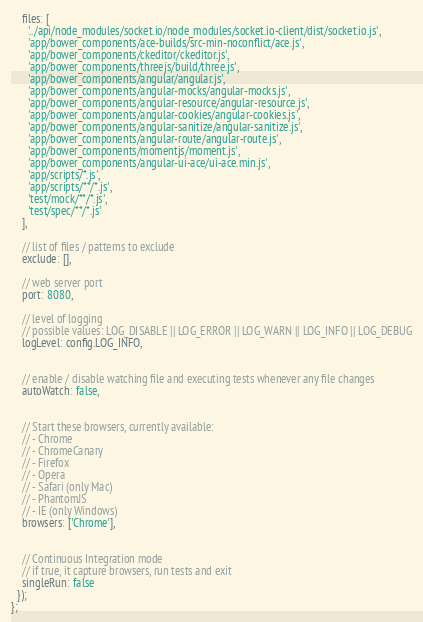Convert code to text. <code><loc_0><loc_0><loc_500><loc_500><_JavaScript_>    files: [
      '../api/node_modules/socket.io/node_modules/socket.io-client/dist/socket.io.js',
      'app/bower_components/ace-builds/src-min-noconflict/ace.js',
      'app/bower_components/ckeditor/ckeditor.js',
      'app/bower_components/threejs/build/three.js',
      'app/bower_components/angular/angular.js',
      'app/bower_components/angular-mocks/angular-mocks.js',
      'app/bower_components/angular-resource/angular-resource.js',
      'app/bower_components/angular-cookies/angular-cookies.js',
      'app/bower_components/angular-sanitize/angular-sanitize.js',
      'app/bower_components/angular-route/angular-route.js',
      'app/bower_components/momentjs/moment.js',
      'app/bower_components/angular-ui-ace/ui-ace.min.js',
      'app/scripts/*.js',
      'app/scripts/**/*.js',
      'test/mock/**/*.js',
      'test/spec/**/*.js'
    ],

    // list of files / patterns to exclude
    exclude: [],

    // web server port
    port: 8080,

    // level of logging
    // possible values: LOG_DISABLE || LOG_ERROR || LOG_WARN || LOG_INFO || LOG_DEBUG
    logLevel: config.LOG_INFO,


    // enable / disable watching file and executing tests whenever any file changes
    autoWatch: false,


    // Start these browsers, currently available:
    // - Chrome
    // - ChromeCanary
    // - Firefox
    // - Opera
    // - Safari (only Mac)
    // - PhantomJS
    // - IE (only Windows)
    browsers: ['Chrome'],


    // Continuous Integration mode
    // if true, it capture browsers, run tests and exit
    singleRun: false
  });
};
</code> 